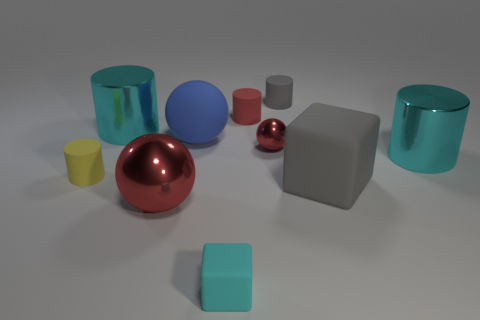How many other rubber objects are the same shape as the big red thing? Including the large red sphere, there is one other sphere in the image that could be made of a material with a rubber-like appearance—it is the smaller, shiny red ball. 